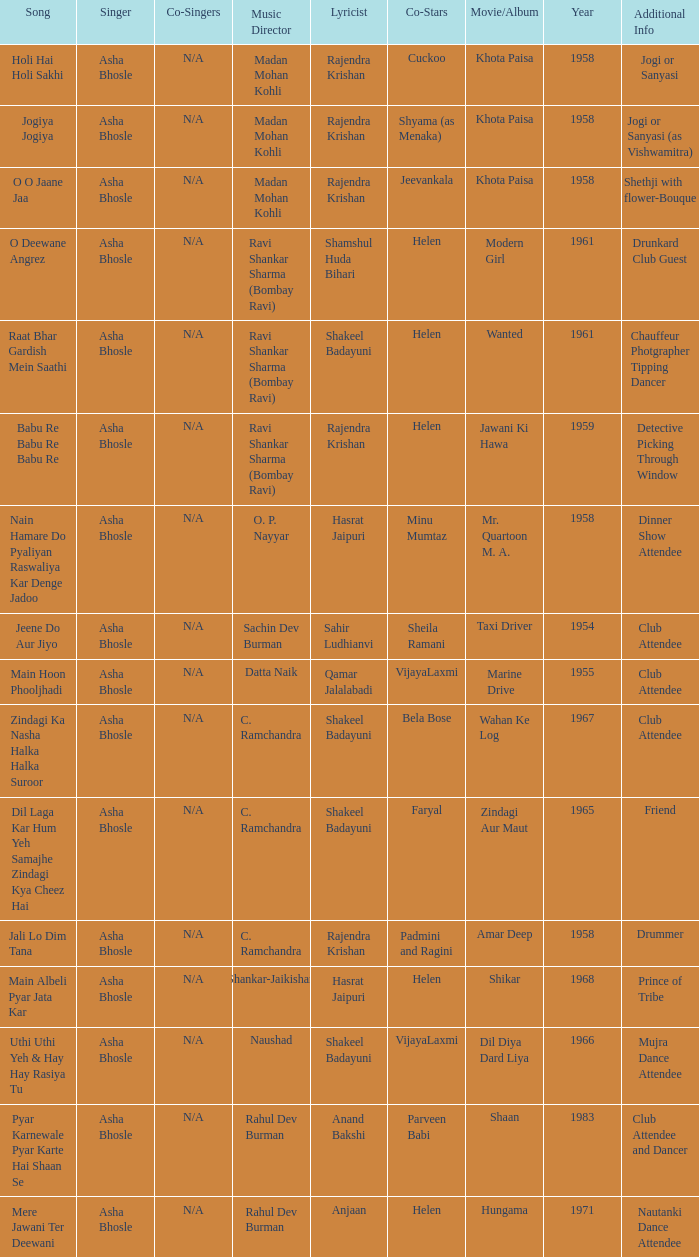What movie did Vijayalaxmi Co-star in and Shakeel Badayuni write the lyrics? Dil Diya Dard Liya. 